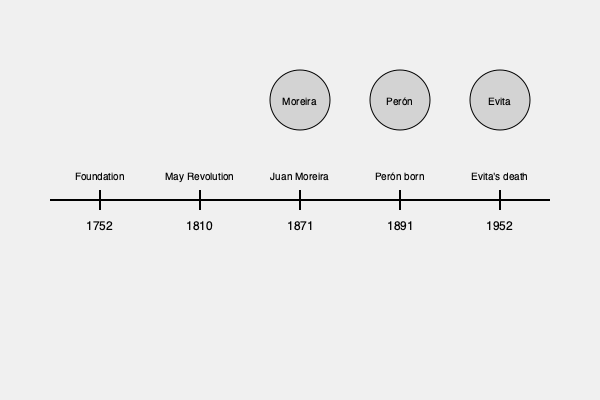Based on the timeline, which local historical figure from Lobos is associated with the earliest event shown? To answer this question, we need to analyze the timeline and identify the local historical figures mentioned:

1. The timeline shows events from 1752 to 1952.
2. Three local figures are depicted: Juan Moreira, Juan Domingo Perón, and Eva Perón (Evita).
3. The events associated with these figures are:
   - 1871: Juan Moreira
   - 1891: Perón born
   - 1952: Evita's death
4. Among these three, the earliest event is associated with Juan Moreira in 1871.
5. The other events (Perón's birth and Evita's death) occurred later.

Therefore, Juan Moreira is the local historical figure associated with the earliest event shown on the timeline.
Answer: Juan Moreira 